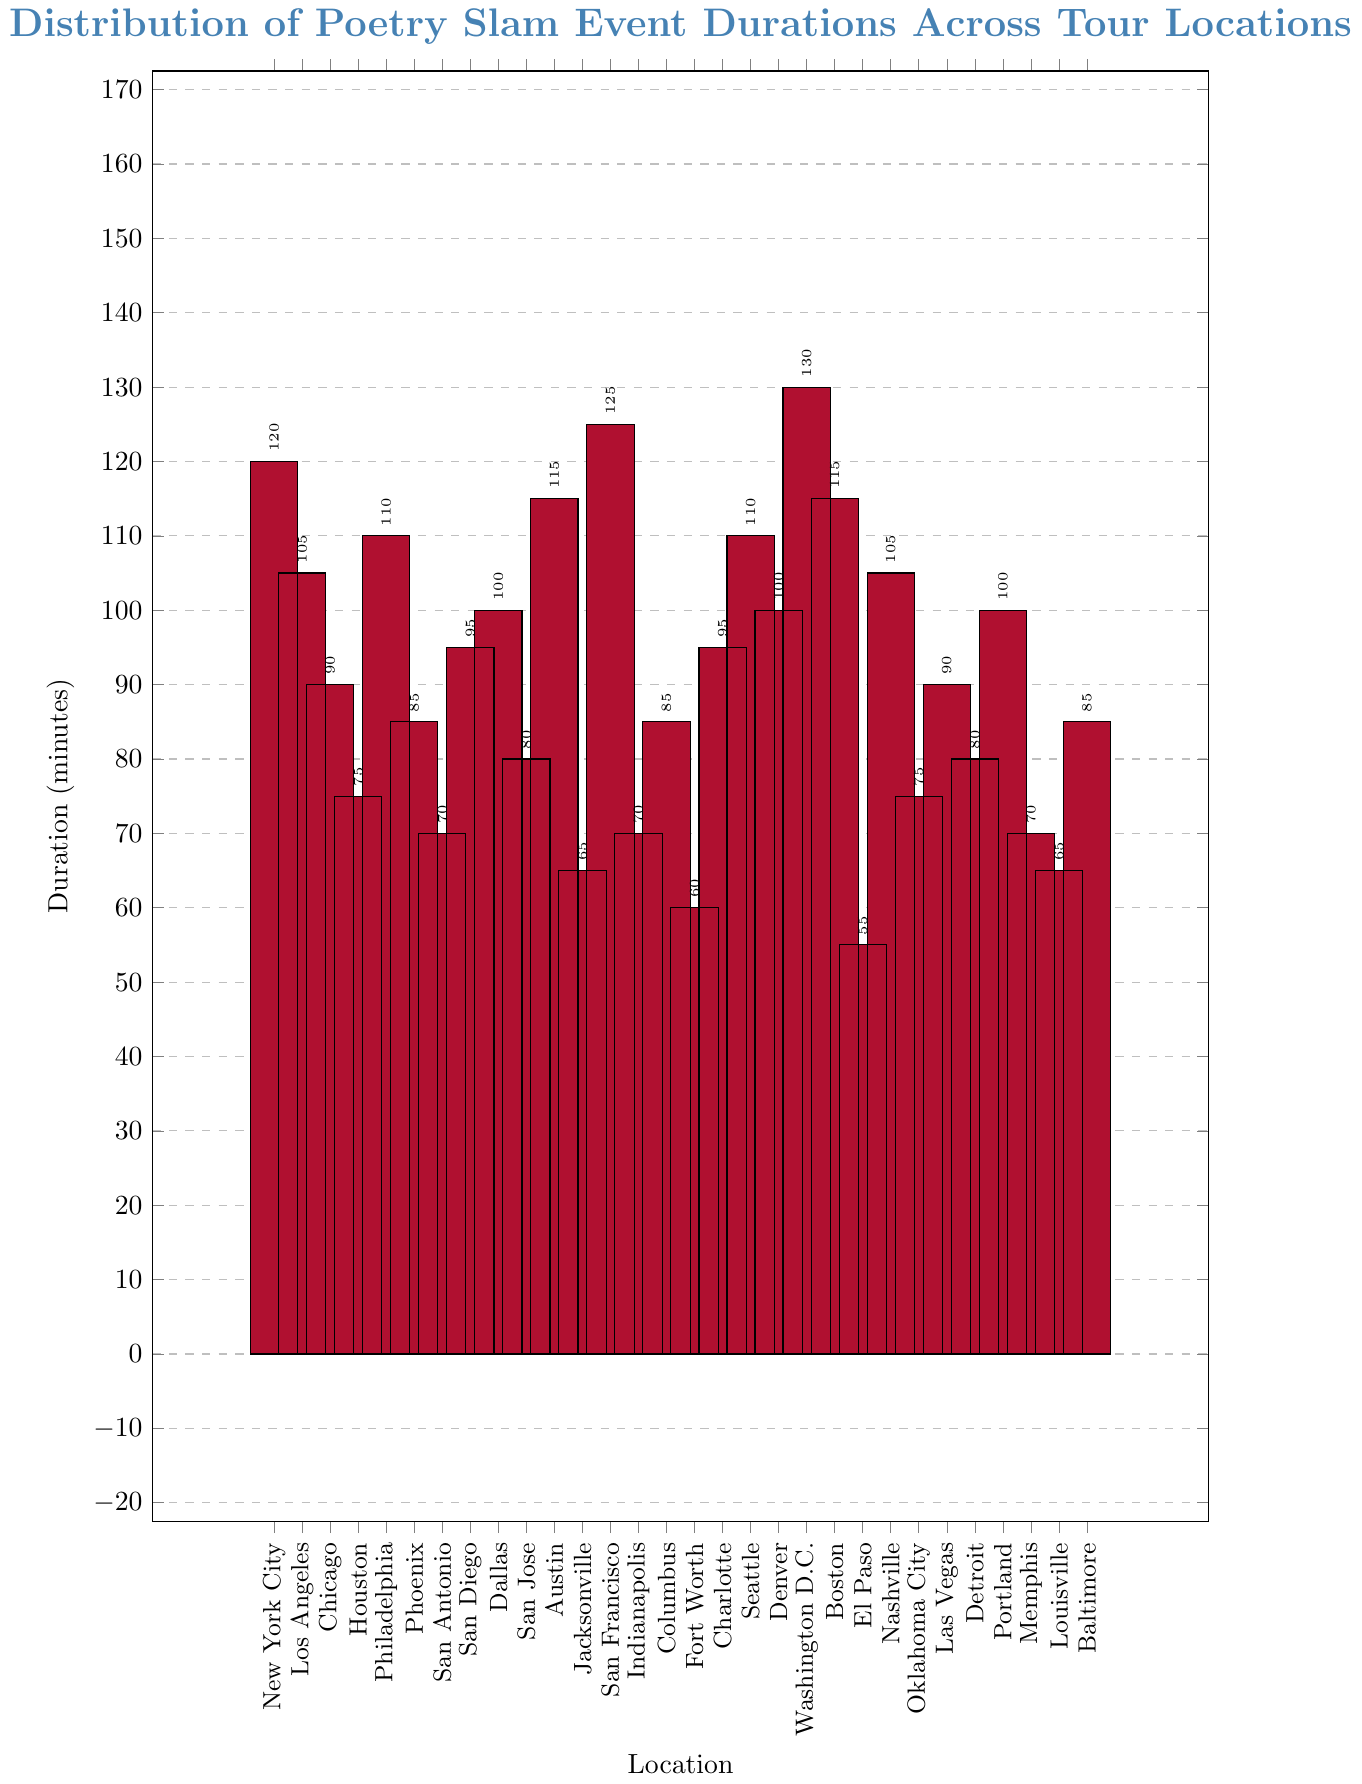What's the duration of the poetry slam event in New York City? The bar corresponding to New York City is labeled with the duration.
Answer: 120 minutes Which locations have a poetry slam event duration less than 70 minutes? Identify the bars with heights below the 70-minute mark and check their labels.
Answer: El Paso, Fort Worth, Jacksonville How much longer is the poetry slam event in Washington D.C. compared to El Paso? Subtract the duration of El Paso (55 minutes) from the duration of Washington D.C. (130 minutes).
Answer: 75 minutes What is the average duration of poetry slam events in Los Angeles, Chicago, and Houston? Add the durations for Los Angeles (105), Chicago (90), and Houston (75), then divide by 3. Calculation: (105+90+75)/3 = 90 minutes.
Answer: 90 minutes Which city has the longest poetry slam event duration, and what is it? Identify the tallest bar and its corresponding city and duration.
Answer: Washington D.C., 130 minutes How many locations have poetry slam events that last exactly 100 minutes? Count the bars labeled with a duration of 100 minutes.
Answer: 3 locations (Dallas, Denver, Portland) What is the difference in poetry slam event duration between the shortest and longest events? Subtract the shortest duration (El Paso, 55 minutes) from the longest duration (Washington D.C., 130 minutes).
Answer: 75 minutes Which two cities have the same poetry slam event duration of 115 minutes? Identify the bars with a duration labeled 115 minutes and check their labels.
Answer: Austin, Boston In how many cities do the poetry slam events last longer than 90 minutes? Count the number of bars that are higher than the 90-minute mark.
Answer: 14 cities What is the total duration of poetry slam events in Phoenix, San Diego, and Charlotte? Add the durations for Phoenix (85), San Diego (95), and Charlotte (95). Calculation: 85+95+95 = 275 minutes.
Answer: 275 minutes 